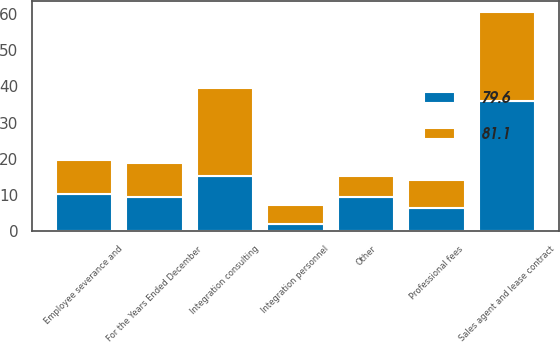<chart> <loc_0><loc_0><loc_500><loc_500><stacked_bar_chart><ecel><fcel>For the Years Ended December<fcel>Sales agent and lease contract<fcel>Integration consulting<fcel>Employee severance and<fcel>Professional fees<fcel>Integration personnel<fcel>Other<nl><fcel>81.1<fcel>9.45<fcel>24.4<fcel>24.2<fcel>9.4<fcel>7.8<fcel>5.2<fcel>5.8<nl><fcel>79.6<fcel>9.45<fcel>36.1<fcel>15.4<fcel>10.2<fcel>6.4<fcel>2<fcel>9.5<nl></chart> 